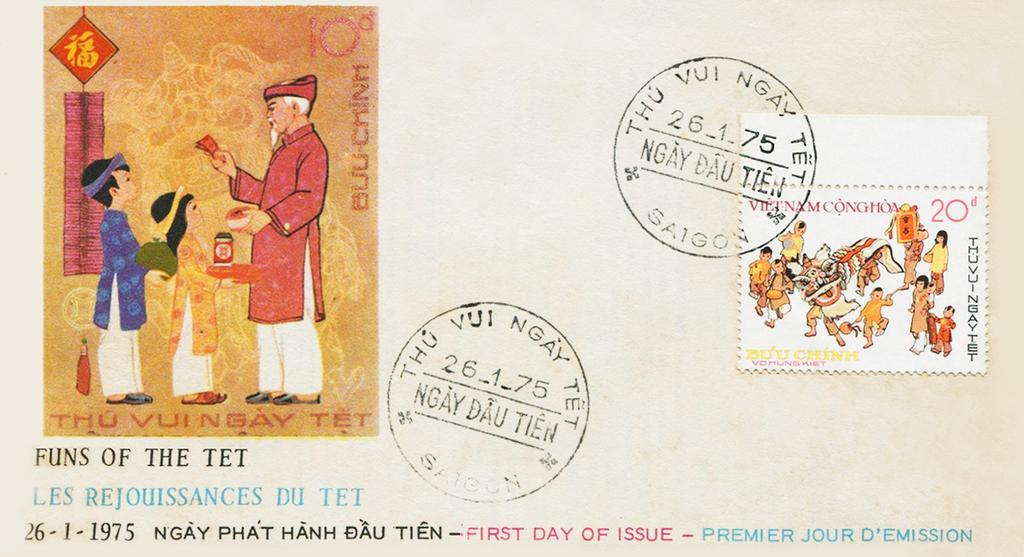Provide a one-sentence caption for the provided image. A postcard with a small picture with the text FUNS OF THE TET underneath it. 